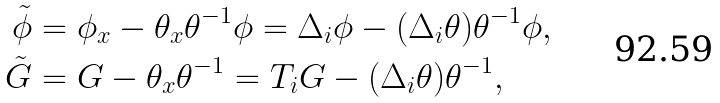<formula> <loc_0><loc_0><loc_500><loc_500>\tilde { \phi } & = \phi _ { x } - \theta _ { x } \theta ^ { - 1 } \phi = \Delta _ { i } \phi - ( \Delta _ { i } \theta ) \theta ^ { - 1 } \phi , \\ \tilde { G } & = G - \theta _ { x } \theta ^ { - 1 } = T _ { i } G - ( \Delta _ { i } \theta ) \theta ^ { - 1 } ,</formula> 